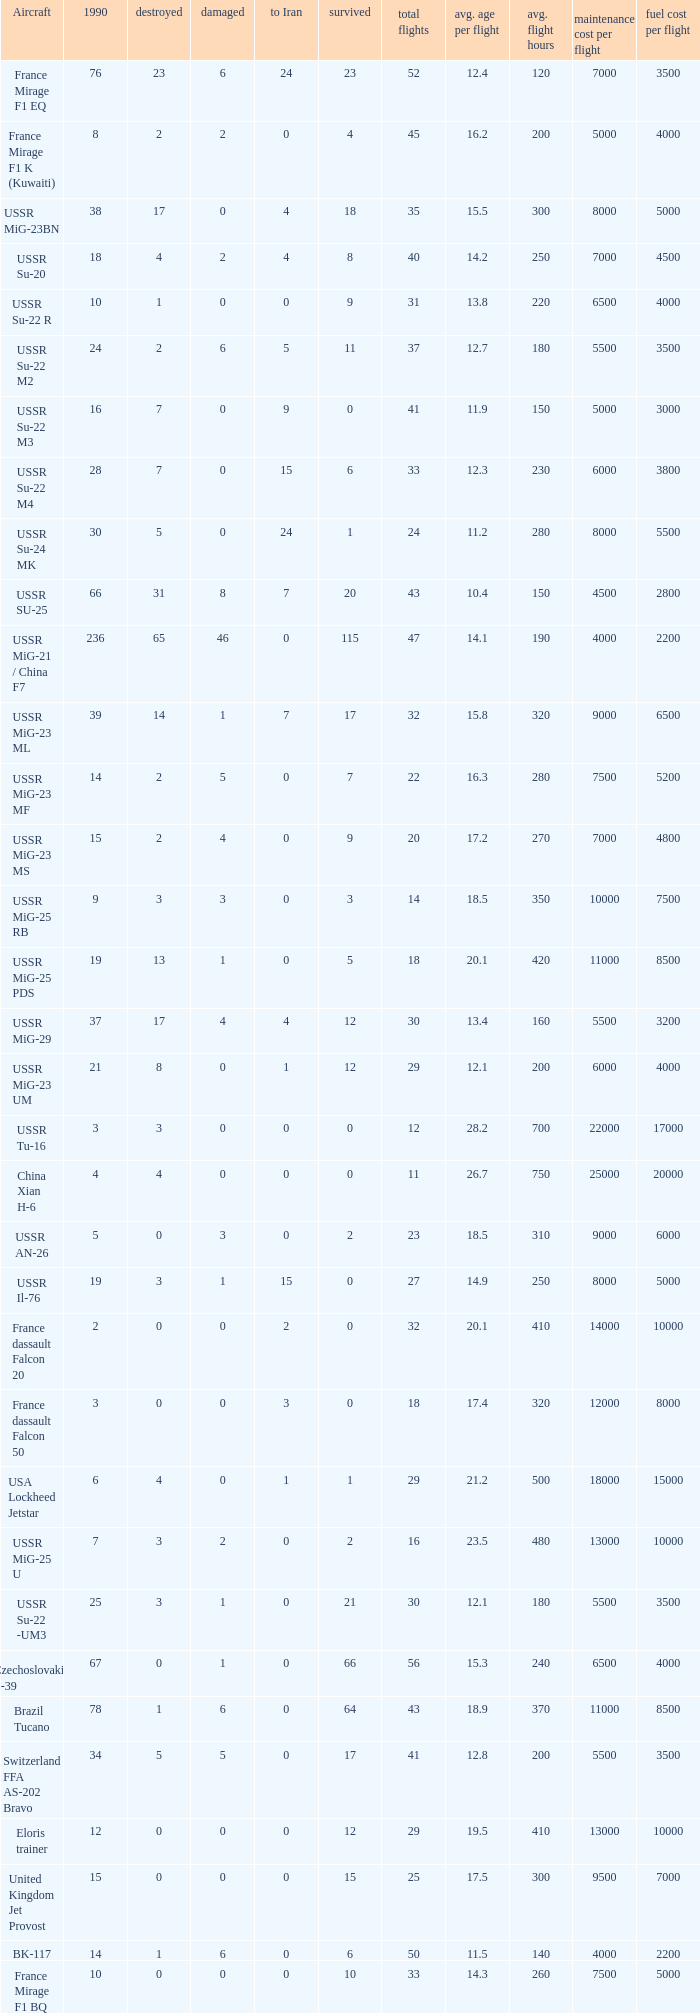If 4 went to iran and the amount that survived was less than 12.0 how many were there in 1990? 1.0. 